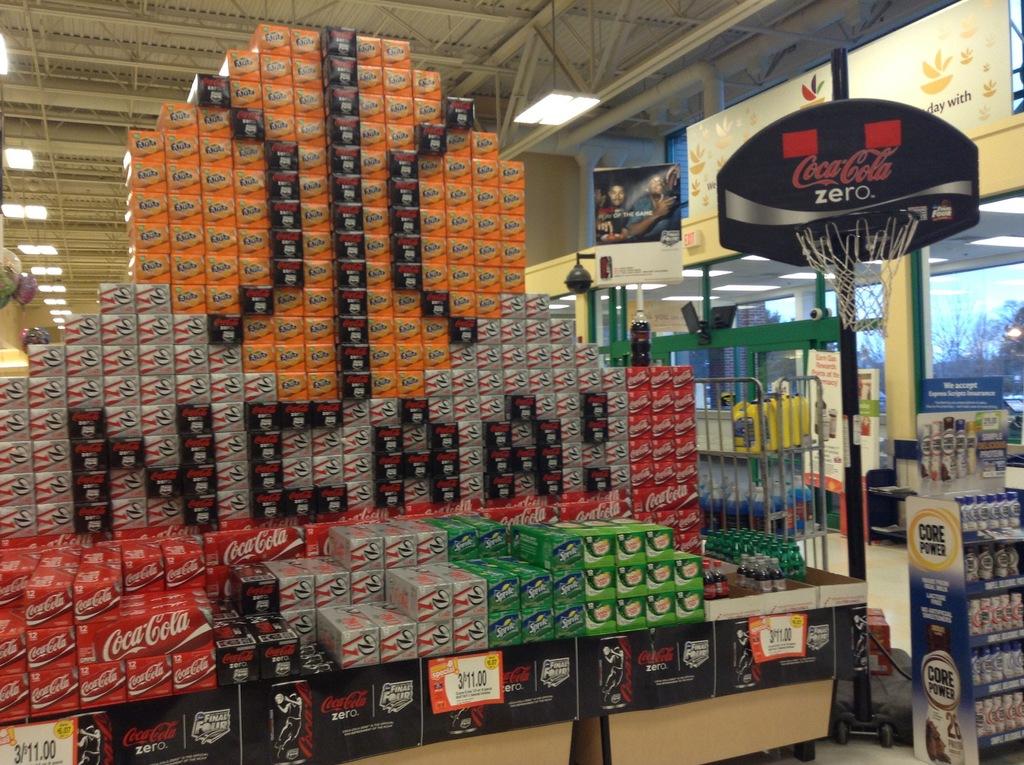What type of soda is on the basketball backboard?
Your response must be concise. Coca cola. What did they spell with the black boxes?
Your answer should be compact. Ncaa. 